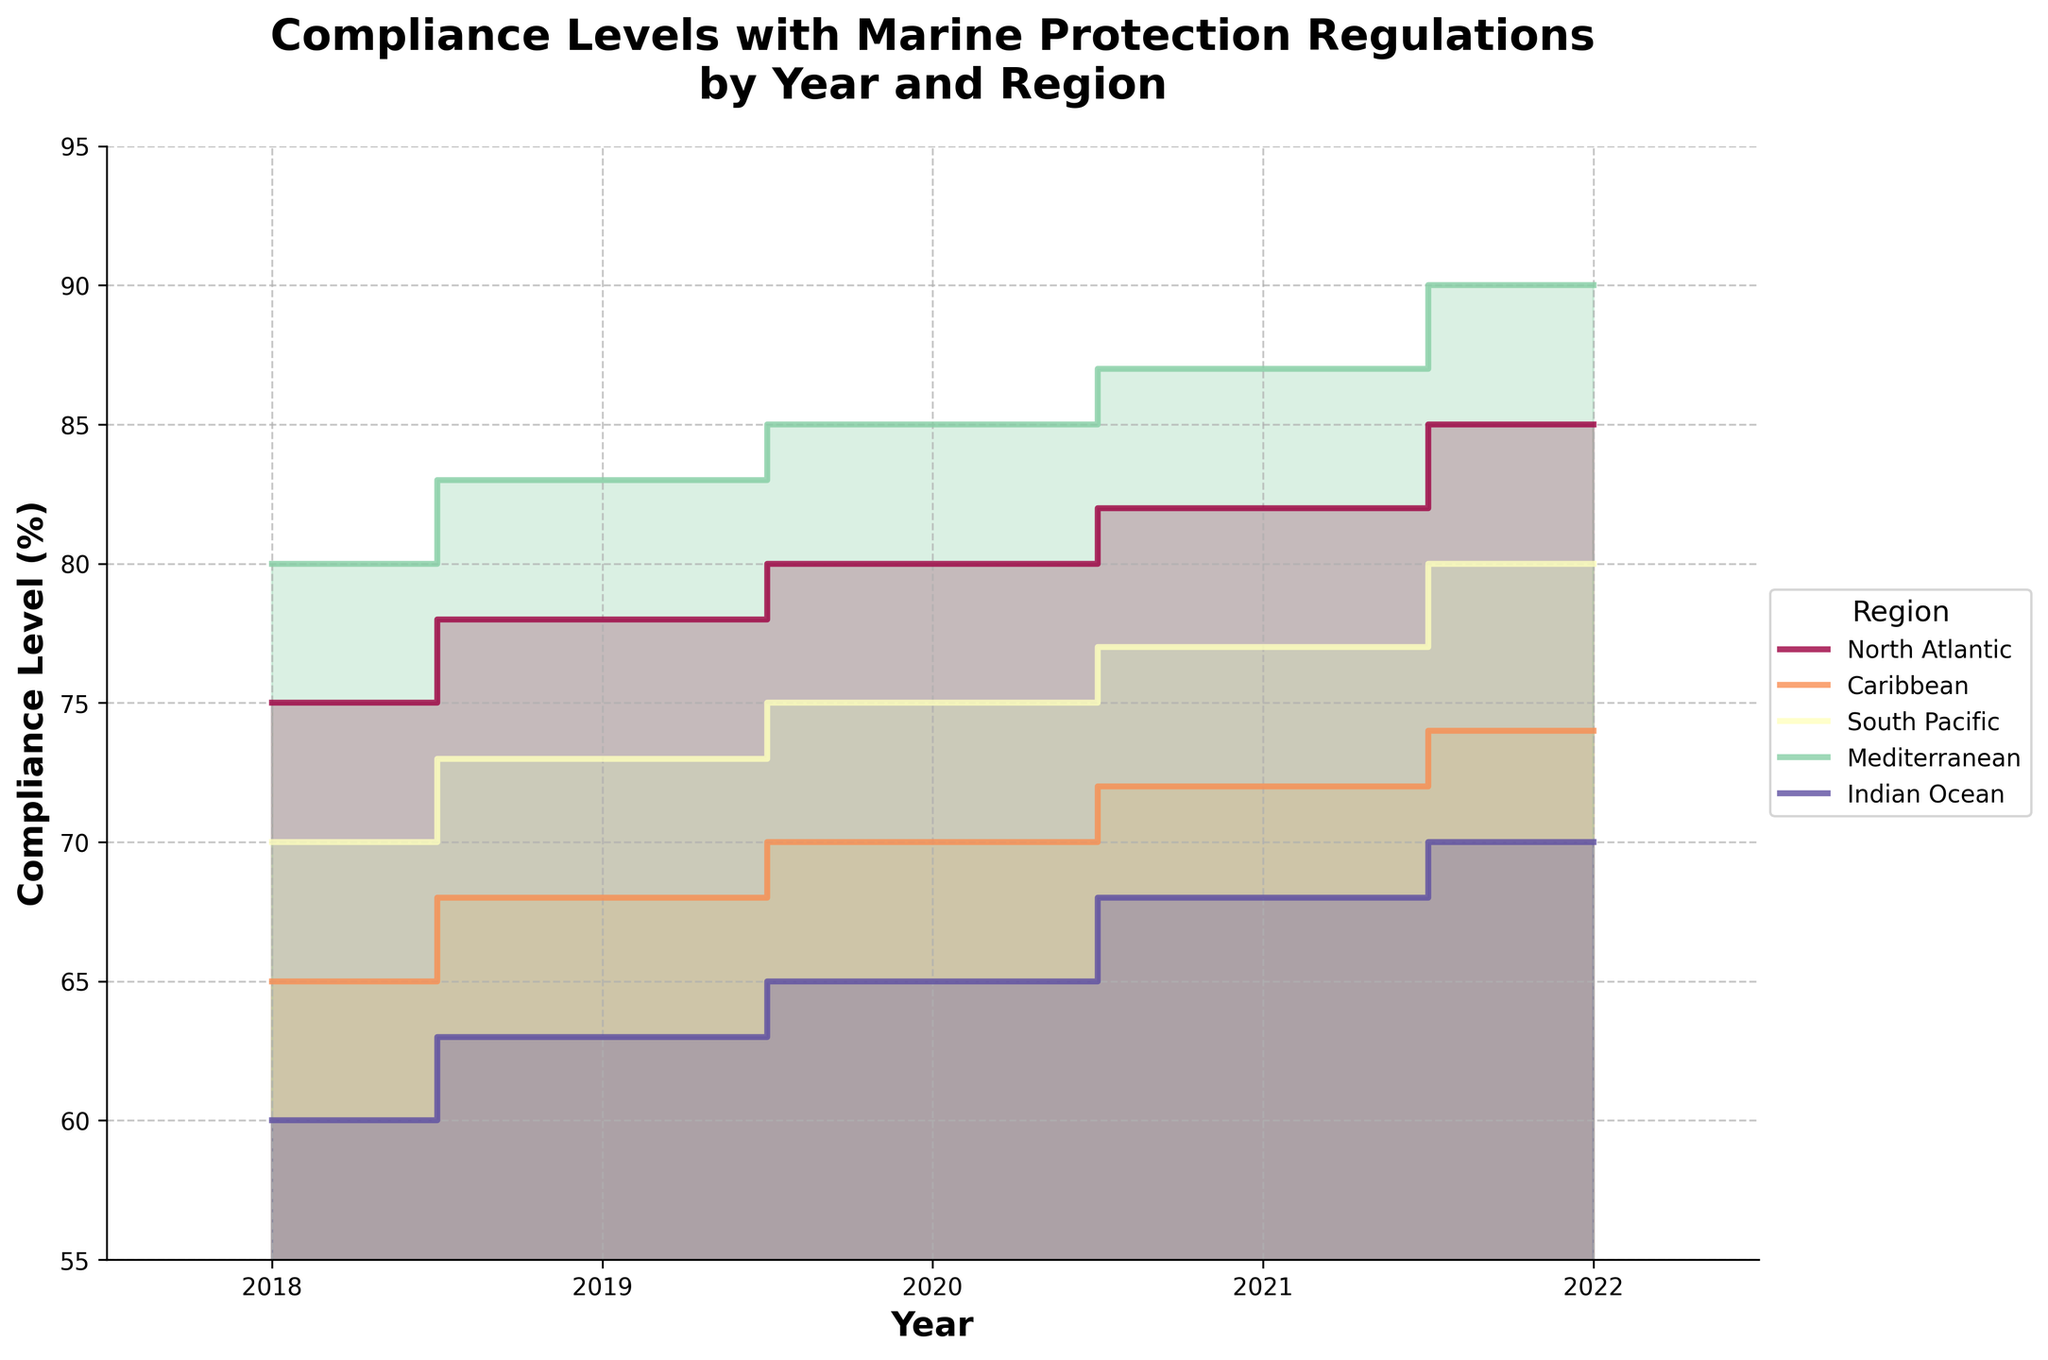What's the title of the chart? The answer to this can be found at the top center of the chart where the title is usually placed.
Answer: Compliance Levels with Marine Protection Regulations\nby Year and Region Which year had the highest compliance level in the North Atlantic region? Look at the North Atlantic region's step line and observe the compliance levels at each year. The highest point on the step line indicates the year with the highest compliance level.
Answer: 2022 What is the range of compliance levels shown on the y-axis? Check the y-axis, which typically shows the range of values representing compliance levels. Identify the minimum and maximum values on this axis.
Answer: 55% to 95% In which region did compliance levels improve consistently every year from 2018 to 2022? Examine each region's step line to see if the compliance levels increase or stay the same every year without any decrease.
Answer: Mediterranean What is the difference in compliance levels between the Caribbean and the Indian Ocean in 2020? Identify the compliance levels for both regions in 2020, then subtract the smaller value from the larger one to find the difference.
Answer: 5% Which region showed the least improvement in compliance levels from 2018 to 2022? Compare the increase in compliance levels for each region from 2018 to 2022 and identify the region with the smallest increase.
Answer: Indian Ocean What was the average compliance level across all regions in 2021? Sum the compliance levels of all regions for 2021 and then divide by the number of regions to get the average.
Answer: 77.2% Comparing compliance levels in 2019 for the Mediterranean and South Pacific regions, which one had a higher compliance level? Refer to the 2019 data points for both Mediterranean and South Pacific regions and compare the compliance levels.
Answer: Mediterranean How many distinct regions are represented in the chart? Look at the legend on the side of the chart which lists all the regions being plotted. Count the total number of regions.
Answer: 5 Is there any year where the North Atlantic region’s compliance level is lower than that of the Caribbean? Compare the compliance levels of the North Atlantic and Caribbean regions for each year to see if there's any point where North Atlantic is lower.
Answer: No 